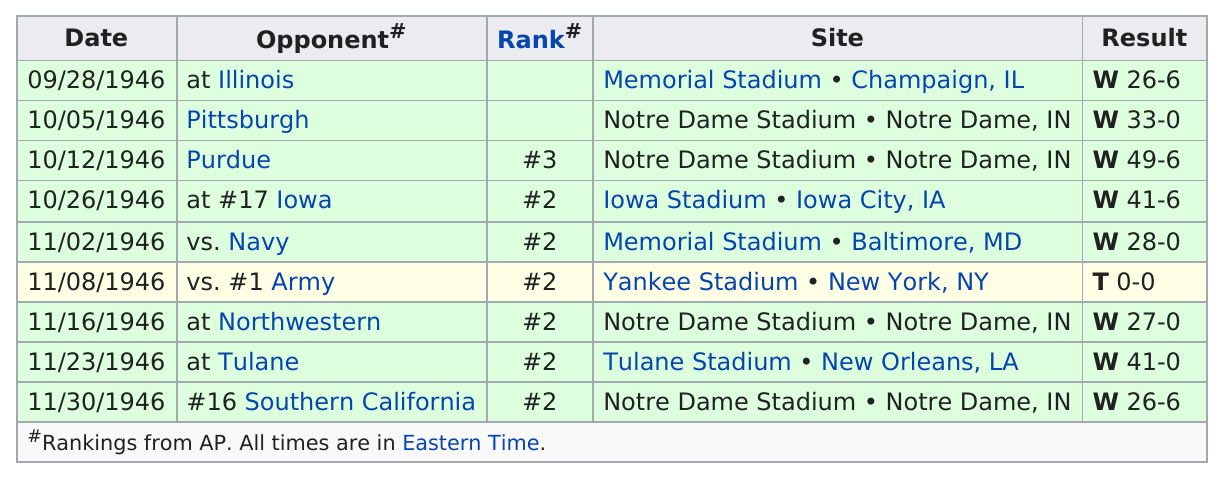Draw attention to some important aspects in this diagram. There are 9 schedule entries in total. The Fighting Irish scored more on average when they were ranked compared to when they were unranked. I can name a team ranked below number two, it is Purdue. As of October 26, the rank from October 12 had increased by one". During the 1946 season, the Notre Dame Fighting Irish played in four stadiums other than Notre Dame Stadium. 